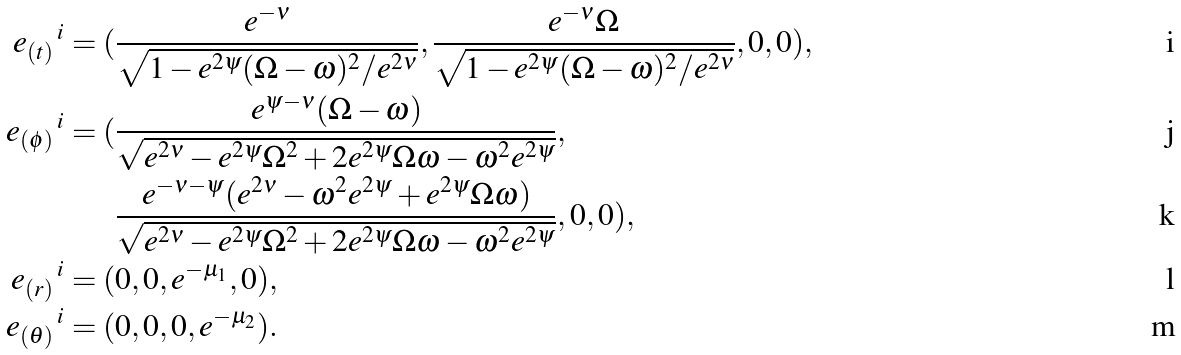<formula> <loc_0><loc_0><loc_500><loc_500>e _ { ( t ) } \, ^ { i } = ( & \frac { e ^ { - \nu } } { \sqrt { 1 - e ^ { 2 \psi } ( \Omega - \omega ) ^ { 2 } / e ^ { 2 \nu } } } , \frac { e ^ { - \nu } \Omega } { \sqrt { 1 - e ^ { 2 \psi } ( \Omega - \omega ) ^ { 2 } / e ^ { 2 \nu } } } , 0 , 0 ) , \\ e _ { ( \phi ) } \, ^ { i } = ( & \frac { e ^ { \psi - \nu } ( \Omega - \omega ) } { \sqrt { e ^ { 2 \nu } - e ^ { 2 \psi } \Omega ^ { 2 } + 2 e ^ { 2 \psi } \Omega \omega - \omega ^ { 2 } e ^ { 2 \psi } } } , \\ & \frac { e ^ { - \nu - \psi } ( e ^ { 2 \nu } - \omega ^ { 2 } { e ^ { 2 \psi } } + e ^ { 2 \psi } \Omega \omega ) } { \sqrt { e ^ { 2 \nu } - e ^ { 2 \psi } \Omega ^ { 2 } + 2 e ^ { 2 \psi } \Omega \omega - { \omega } ^ { 2 } { e ^ { 2 \psi } } } } , 0 , 0 ) , \\ e _ { ( r ) } \, ^ { i } = ( & 0 , 0 , e ^ { - \mu _ { 1 } } , 0 ) , \\ e _ { ( \theta ) } \, ^ { i } = ( & 0 , 0 , 0 , e ^ { - \mu _ { 2 } } ) .</formula> 